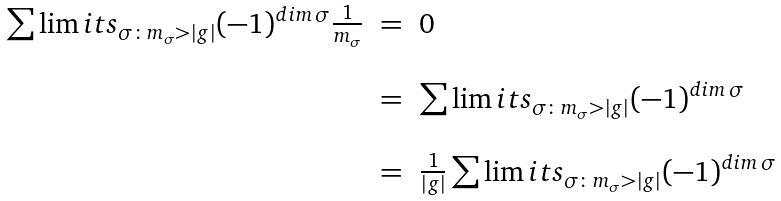Convert formula to latex. <formula><loc_0><loc_0><loc_500><loc_500>\begin{array} { r c l } \sum \lim i t s _ { \sigma \colon m _ { \sigma } > | g | } ( - 1 ) ^ { d i m \, \sigma } \frac { 1 } { m _ { \sigma } } & = & 0 \\ \\ & = & \sum \lim i t s _ { \sigma \colon m _ { \sigma } > | g | } ( - 1 ) ^ { d i m \, \sigma } \\ \\ & = & \frac { 1 } { | g | } \sum \lim i t s _ { \sigma \colon m _ { \sigma } > | g | } ( - 1 ) ^ { d i m \, \sigma } \end{array}</formula> 